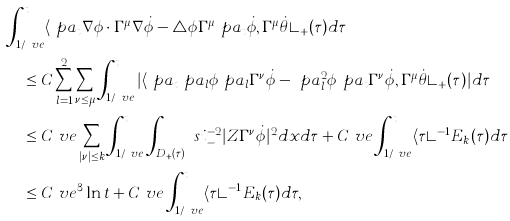Convert formula to latex. <formula><loc_0><loc_0><loc_500><loc_500>& \int _ { 1 / \ v e } ^ { t } \langle \ p a _ { t } \nabla \phi \cdot \Gamma ^ { \mu } \nabla \dot { \phi } - \triangle \phi \Gamma ^ { \mu } \ p a _ { t } \dot { \phi } , \Gamma ^ { \mu } \dot { \theta } \rangle _ { + } ( \tau ) d \tau \\ & \quad \leq C \sum _ { l = 1 } ^ { 2 } \sum _ { \nu \leq \mu } \int _ { 1 / \ v e } ^ { t } | \langle \ p a _ { t } \ p a _ { l } \phi \ p a _ { l } \Gamma ^ { \nu } \dot { \phi } - \ p a _ { l } ^ { 2 } \phi \ p a _ { t } \Gamma ^ { \nu } \dot { \phi } , \Gamma ^ { \mu } \dot { \theta } \rangle _ { + } ( \tau ) | d \tau \\ & \quad \leq C \ v e \sum _ { | \nu | \leq k } \int _ { 1 / \ v e } ^ { t } \int _ { D _ { + } ( \tau ) } \ s i _ { - } ^ { - 2 } | Z \Gamma ^ { \nu } \dot { \phi } | ^ { 2 } d x d \tau + C \ v e \int _ { 1 / \ v e } ^ { t } \langle \tau \rangle ^ { - 1 } E _ { k } ( \tau ) d \tau \\ & \quad \leq C \ v e ^ { 3 } \ln t + C \ v e \int _ { 1 / \ v e } ^ { t } \langle \tau \rangle ^ { - 1 } E _ { k } ( \tau ) d \tau ,</formula> 